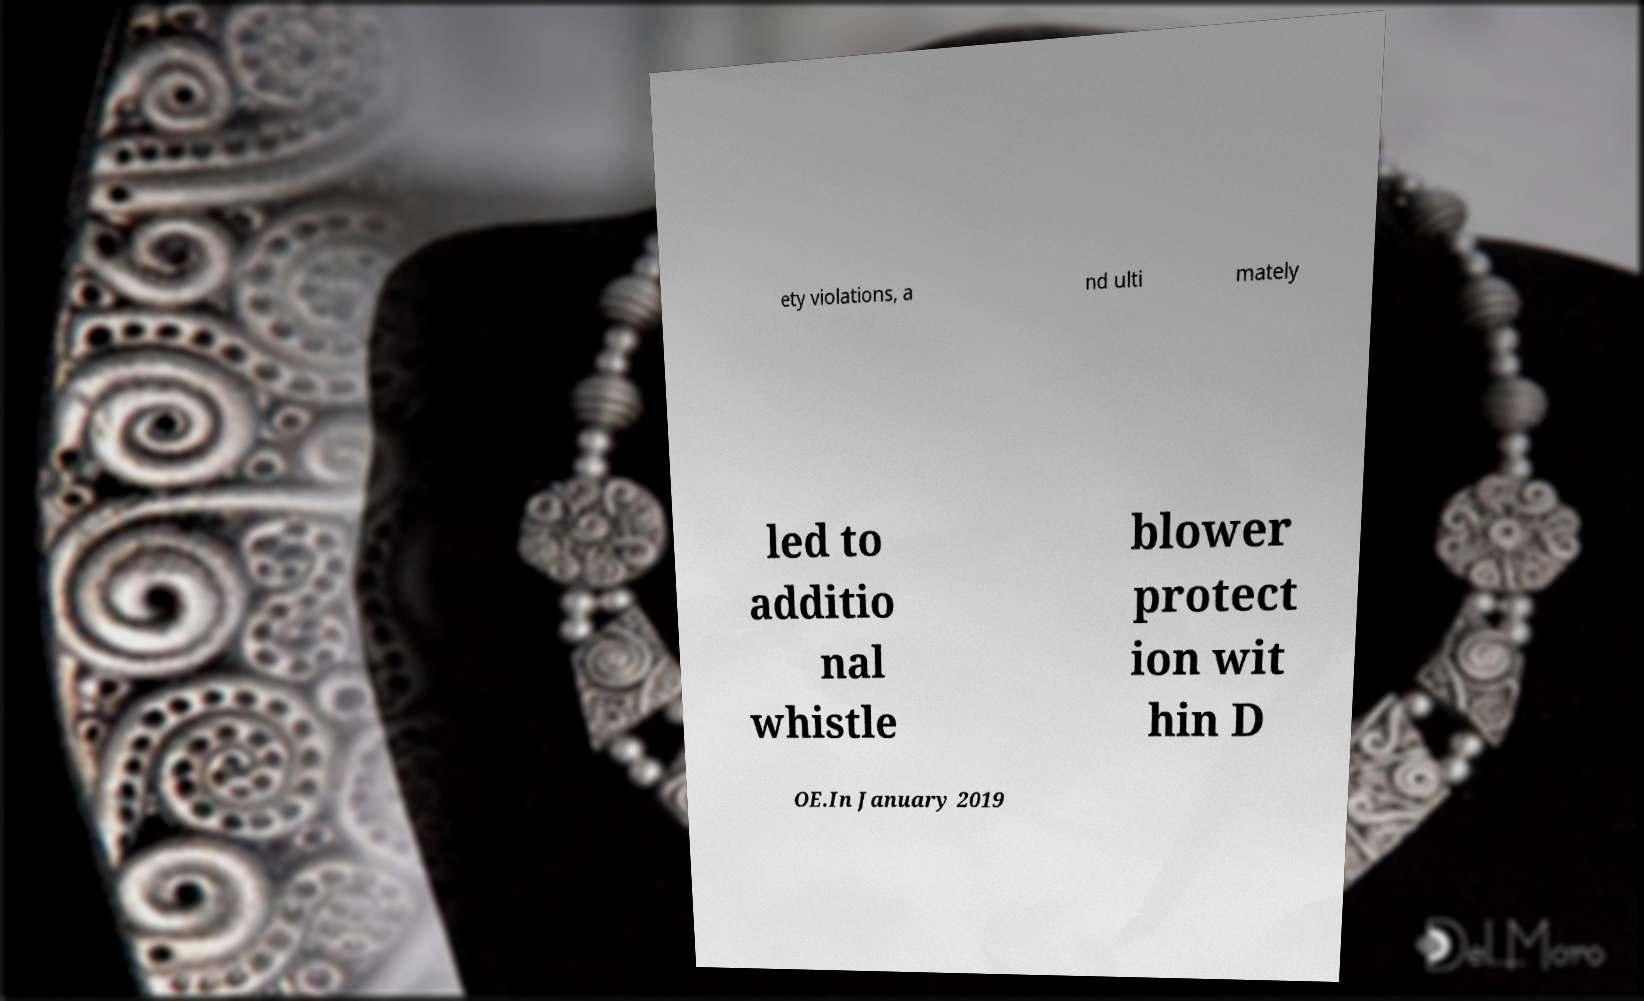Please identify and transcribe the text found in this image. ety violations, a nd ulti mately led to additio nal whistle blower protect ion wit hin D OE.In January 2019 